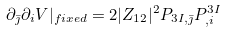<formula> <loc_0><loc_0><loc_500><loc_500>\partial _ { \bar { \jmath } } \partial _ { i } V | _ { f i x e d } = 2 | Z _ { 1 2 } | ^ { 2 } P _ { 3 I , \bar { \jmath } } P ^ { 3 I } _ { , i }</formula> 